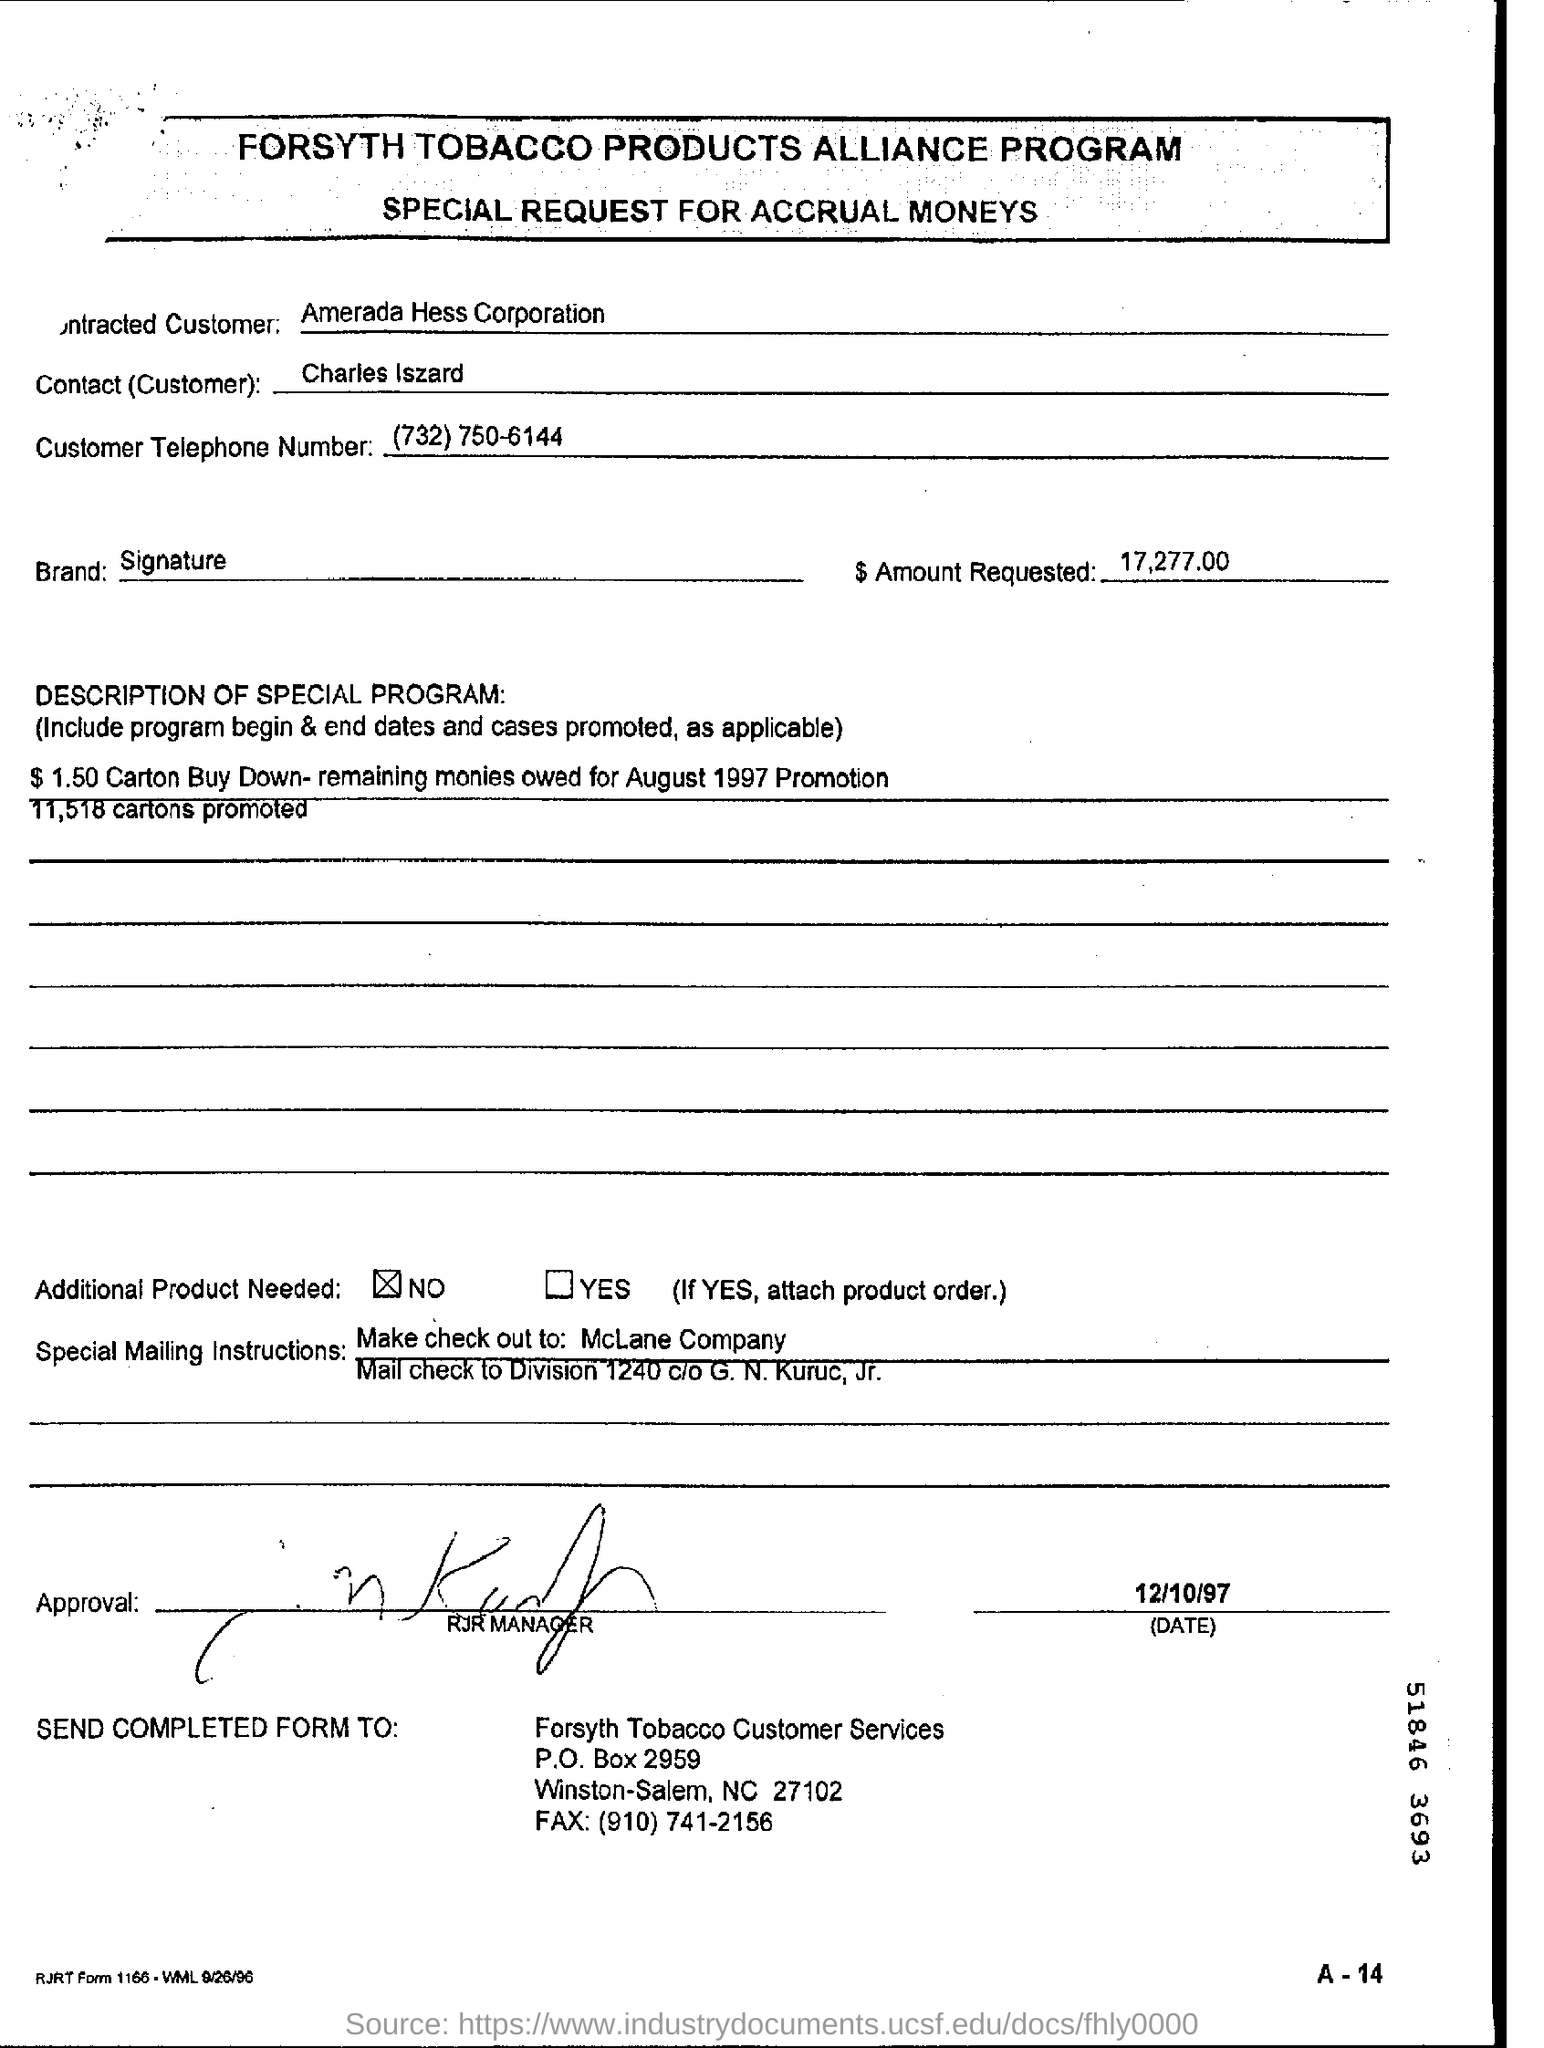Draw attention to some important aspects in this diagram. A total of 11,158 cartons were promoted. The amount requested for tobacco products is 17,277.00. The customer's telephone number is (732) 750-6144. The name of the contact (customer) is Charles Iszard. 